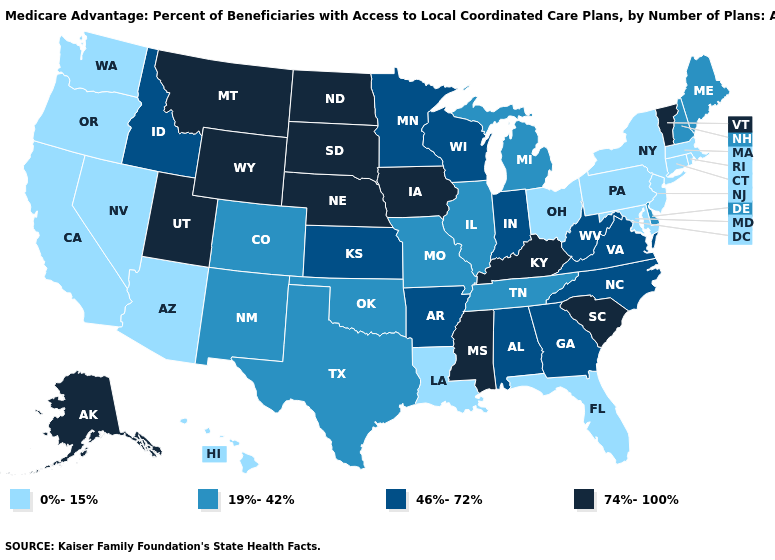Does Kentucky have the lowest value in the USA?
Concise answer only. No. Among the states that border Arizona , does Utah have the highest value?
Be succinct. Yes. Name the states that have a value in the range 46%-72%?
Quick response, please. Alabama, Arkansas, Georgia, Idaho, Indiana, Kansas, Minnesota, North Carolina, Virginia, Wisconsin, West Virginia. What is the value of Arizona?
Write a very short answer. 0%-15%. Which states have the highest value in the USA?
Concise answer only. Alaska, Iowa, Kentucky, Mississippi, Montana, North Dakota, Nebraska, South Carolina, South Dakota, Utah, Vermont, Wyoming. What is the value of Alabama?
Give a very brief answer. 46%-72%. Which states hav the highest value in the South?
Write a very short answer. Kentucky, Mississippi, South Carolina. What is the value of Michigan?
Give a very brief answer. 19%-42%. Name the states that have a value in the range 19%-42%?
Short answer required. Colorado, Delaware, Illinois, Maine, Michigan, Missouri, New Hampshire, New Mexico, Oklahoma, Tennessee, Texas. Does Arkansas have the lowest value in the USA?
Quick response, please. No. Name the states that have a value in the range 46%-72%?
Keep it brief. Alabama, Arkansas, Georgia, Idaho, Indiana, Kansas, Minnesota, North Carolina, Virginia, Wisconsin, West Virginia. Does Minnesota have a lower value than Oregon?
Concise answer only. No. Among the states that border Michigan , does Ohio have the lowest value?
Give a very brief answer. Yes. Does Michigan have a lower value than New York?
Short answer required. No. Does New Mexico have a higher value than Rhode Island?
Answer briefly. Yes. 